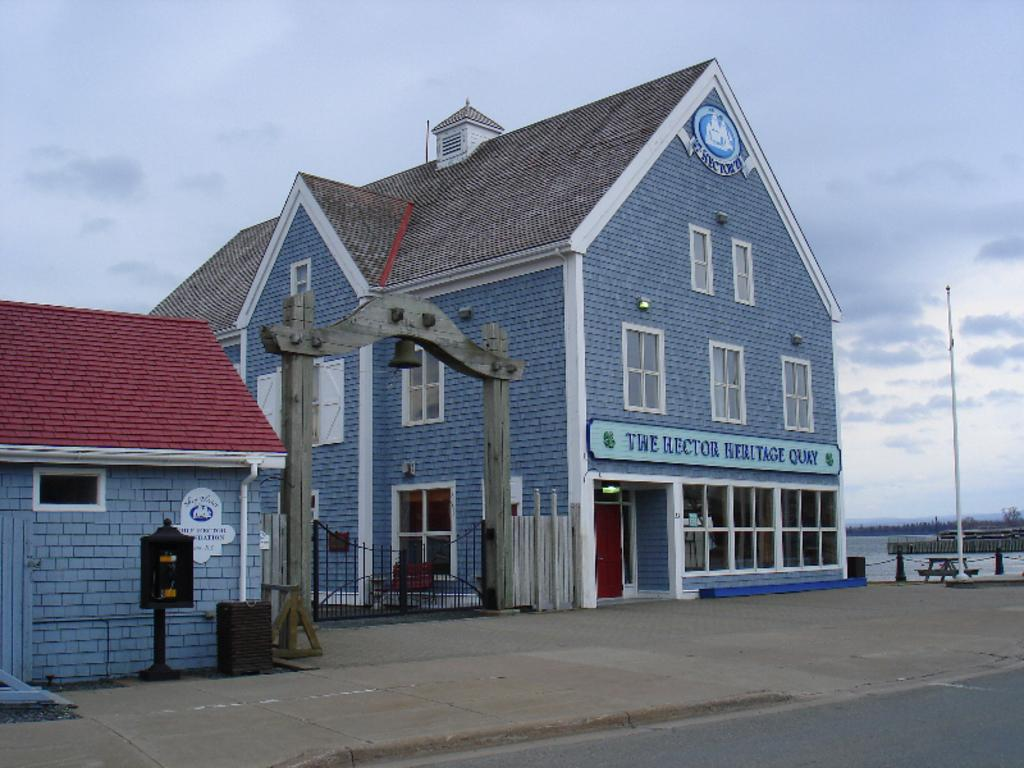What type of structures can be seen in the image? There are buildings with windows and roofs in the image. What object is present in the image that might be used for displaying information or announcements? There is a board in the image. Where is the bell located in the image? The bell is on an arch in the image. What architectural feature is present in the image that might control access to a specific area? There is a gate in the image. What type of vertical structures can be seen in the image? There are poles in the image. What natural feature is present in the image? There is a water body in the image. What type of vegetation can be seen in the image? There is a group of trees in the image. What part of the natural environment is visible in the image? The sky is visible in the image. What type of government is depicted in the image? There is no indication of a specific government or political system in the image. Can you tell me how many daughters are present in the image? There is no mention of any daughters or people in the image; it primarily features structures, objects, and natural elements. 